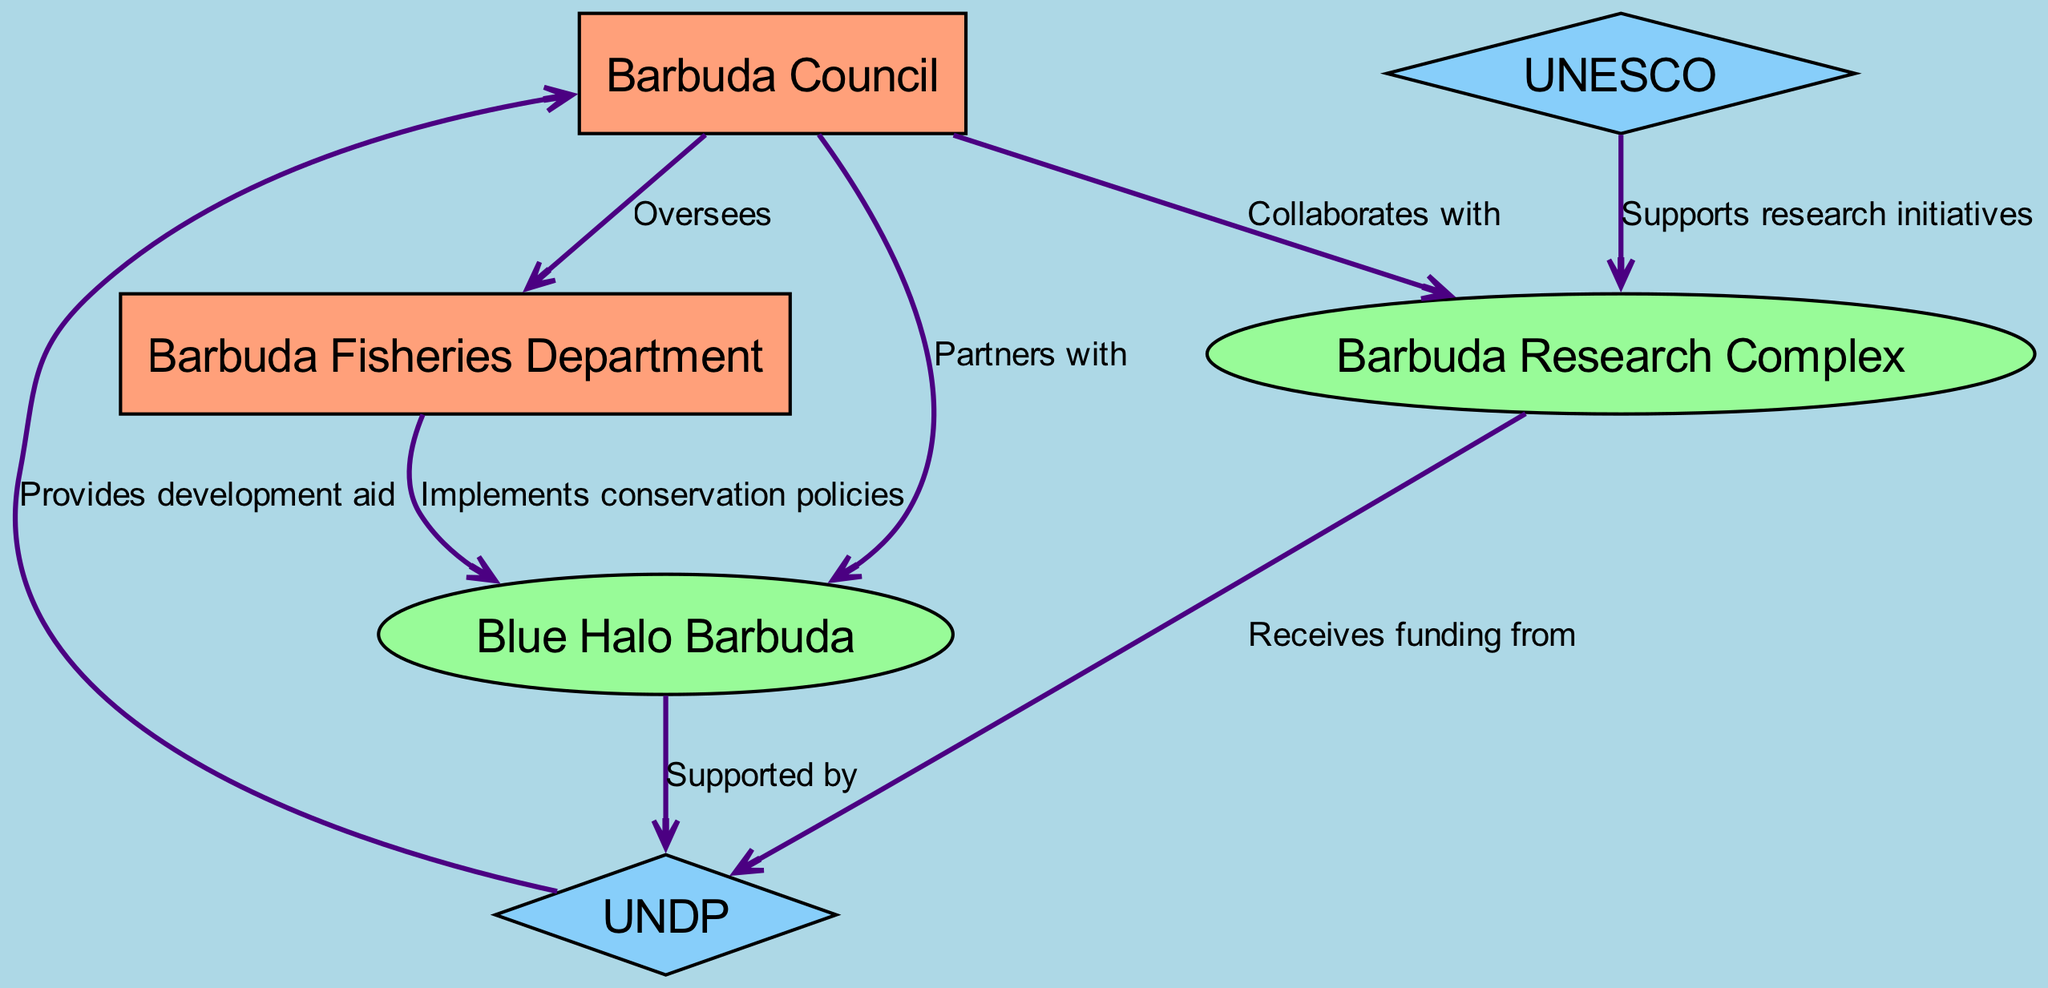What is the name of the local government in Barbuda? The diagram identifies the local government as "Barbuda Council" under the "Local Government" category.
Answer: Barbuda Council How many NGOs are represented in the diagram? The diagram lists two organizations labeled as NGOs, namely "Barbuda Research Complex" and "Blue Halo Barbuda." Thus, the count is two.
Answer: 2 Which organization oversees the Barbuda Fisheries Department? The edge from "Barbuda Council" to "Barbuda Fisheries Department" indicates that it "Oversees" this department, so the overseeing organization is the Barbuda Council.
Answer: Barbuda Council What relationship does the Barbuda Council have with the Barbuda Research Complex? The edge shows that the Barbuda Council "Collaborates with" the Barbuda Research Complex, indicating their active partnership.
Answer: Collaborates with Which organization provides development aid to the local government? The incoming edge to "Barbuda Council" from "UNDP" indicates that UNDP "Provides development aid" to the Barbuda Council, so UNDP is the organization.
Answer: UNDP How does the Barbuda Fisheries Department interact with Blue Halo Barbuda? There is an edge labeled "Implements conservation policies" from the Barbuda Fisheries Department to Blue Halo Barbuda, indicating their interaction is based on conservation initiatives.
Answer: Implements conservation policies What type of organization is UNESCO classified as in the diagram? The node for UNESCO is marked as an "International Organization" according to the classification made visually in the diagram.
Answer: International Organization Which NGO receives funding from the UNDP? The diagram indicates that "Barbuda Research Complex" receives funding from "UNDP," confirmed by the edge labeled "Receives funding from."
Answer: Barbuda Research Complex What is the type of relationship between Blue Halo Barbuda and UNDP? The edge shows that Blue Halo Barbuda is "Supported by" UNDP, which classifies their relationship as supportive in nature.
Answer: Supported by 